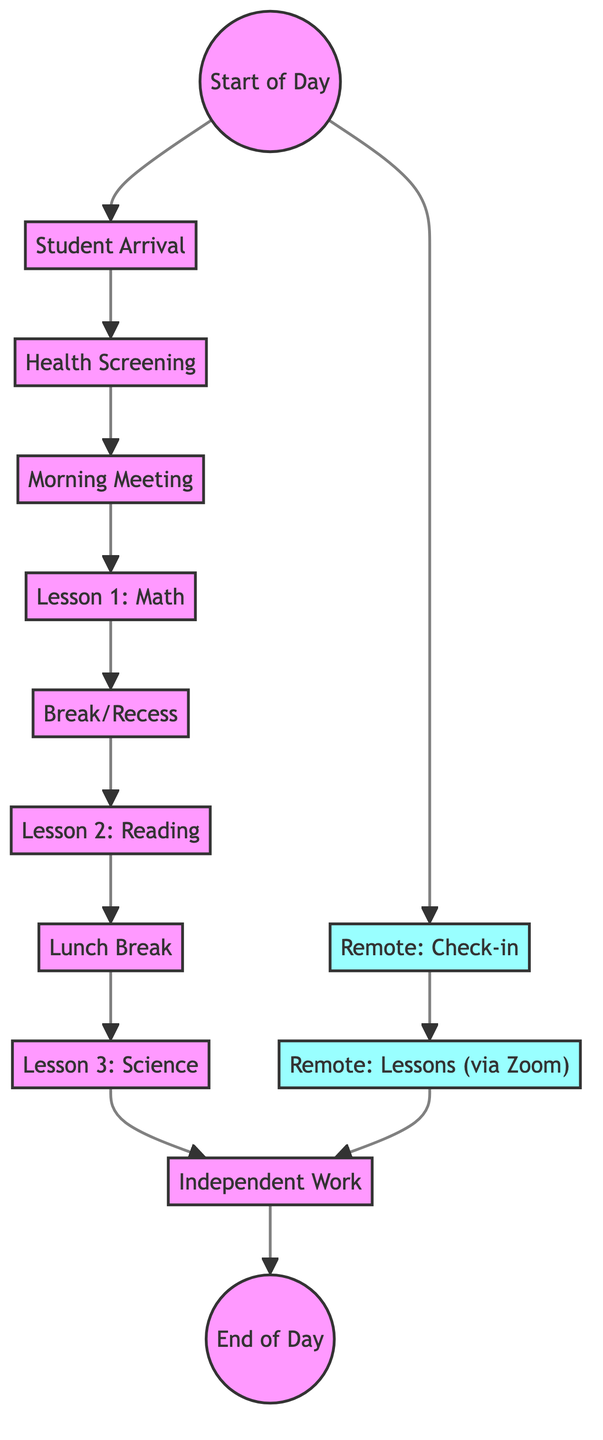What is the first activity that occurs after the start of the day? The diagram shows that after the "Start of Day" node, the next node connected is "Student Arrival." Therefore, the first activity is "Student Arrival."
Answer: Student Arrival How many lessons are scheduled for in-person students? By counting the number of lesson nodes in the directed graph, I find that there are three lessons (“Lesson 1: Math,” “Lesson 2: Reading,” and “Lesson 3: Science”).
Answer: 3 What transition occurs after the health screening? After the "Health Screening" node, the next node is "Morning Meeting," indicating that students move to the morning meeting after screening.
Answer: Morning Meeting Which type of students check in remotely? The node labeled "Remote: Check-in" specifically indicates that it is designated for remote students, so the answer pertains to students who are learning remotely.
Answer: Remote students What is the last activity listed before the end of the day? The activity that directly connects to "End of Day" in the graph is "Independent Work." Therefore, before the day ends, students will engage in independent work.
Answer: Independent Work How many nodes are dedicated to remote learning? The nodes related to remote learning are "Remote: Check-in," "Remote: Lessons (via Zoom)," and they connect to "Independent Work." Thus, there are three nodes dedicated to remote learning.
Answer: 3 How does a remote student’s schedule differ from an in-person student after the start of the day? After the "Start of Day" node, in-person students go to "Student Arrival," while remote students proceed to "Remote: Check-in." This indicates the point of divergence between in-person and remote schedules.
Answer: Diverges at Remote Check-in What is the total number of activities listed in the diagram? By counting all the nodes in the graph (including start and end points), we find there are a total of thirteen activities.
Answer: 13 